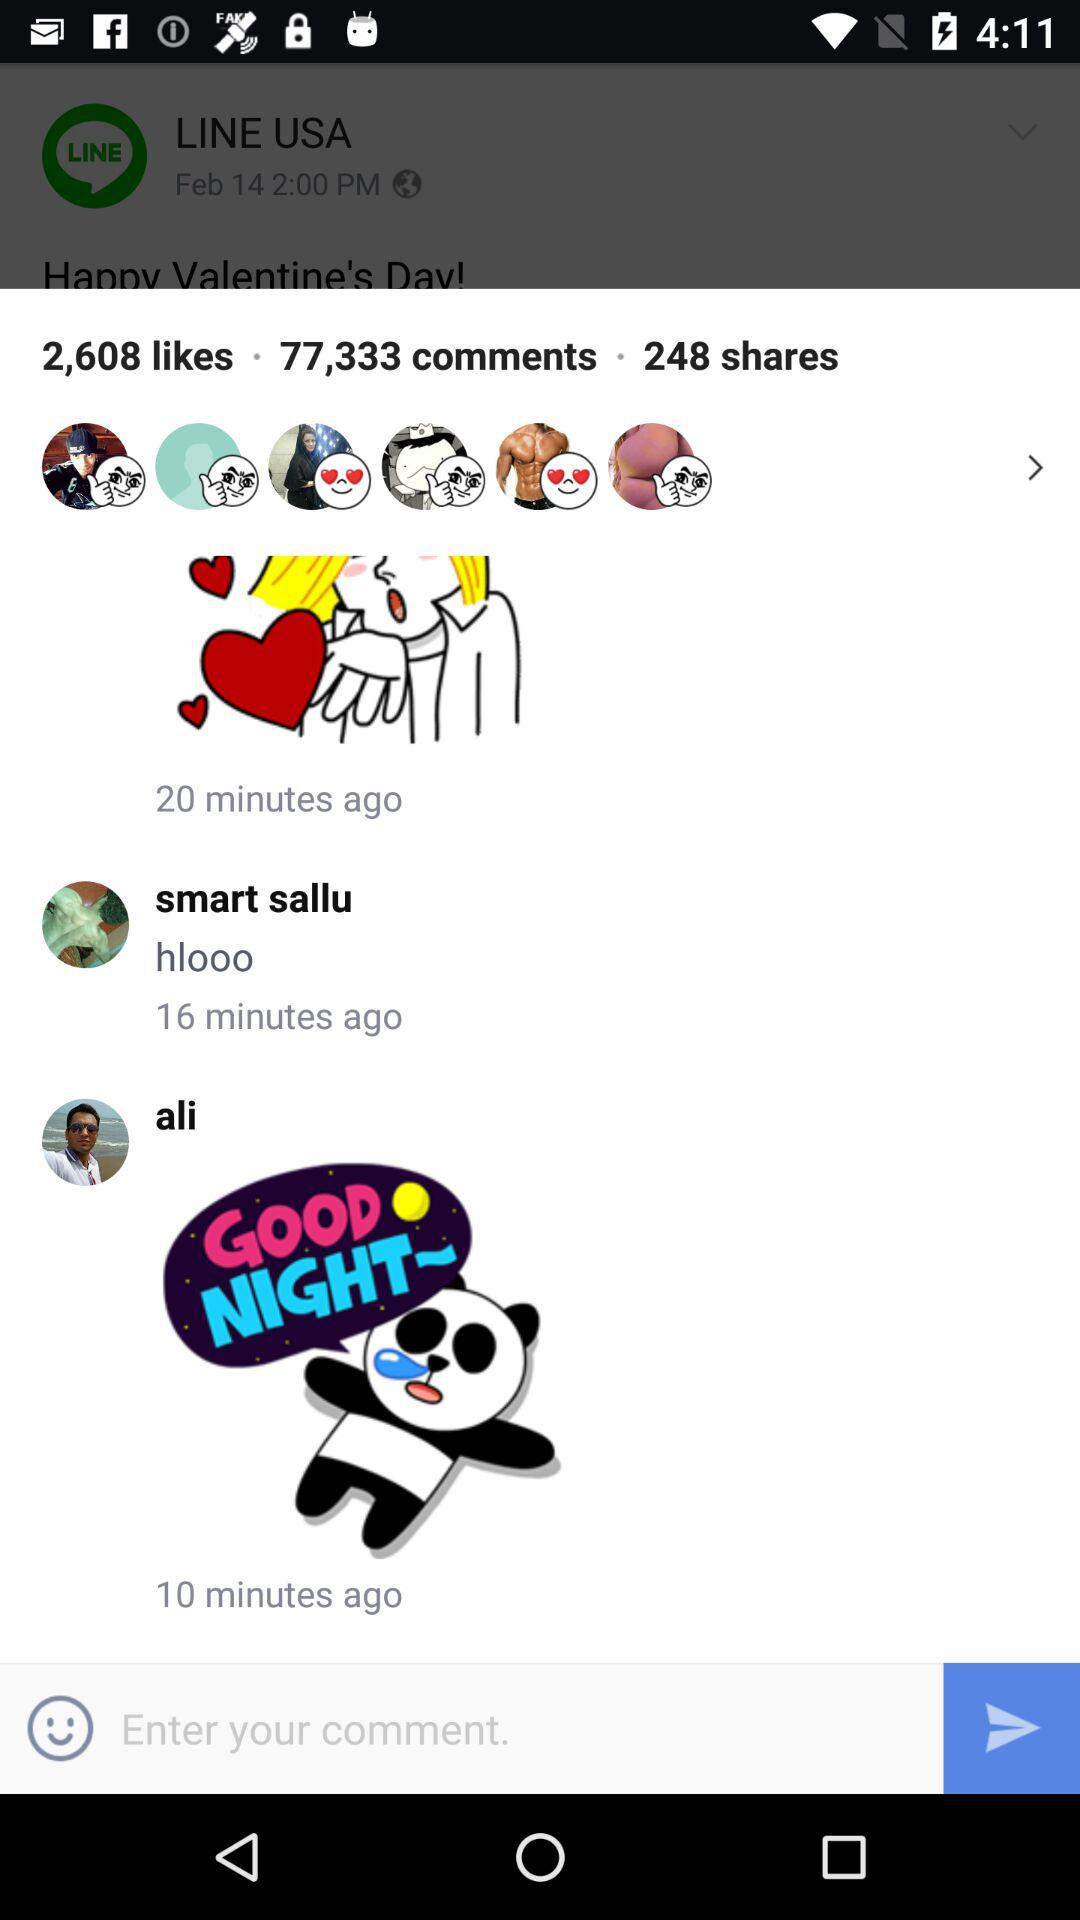How many likes are there? There are 2,608 likes. 